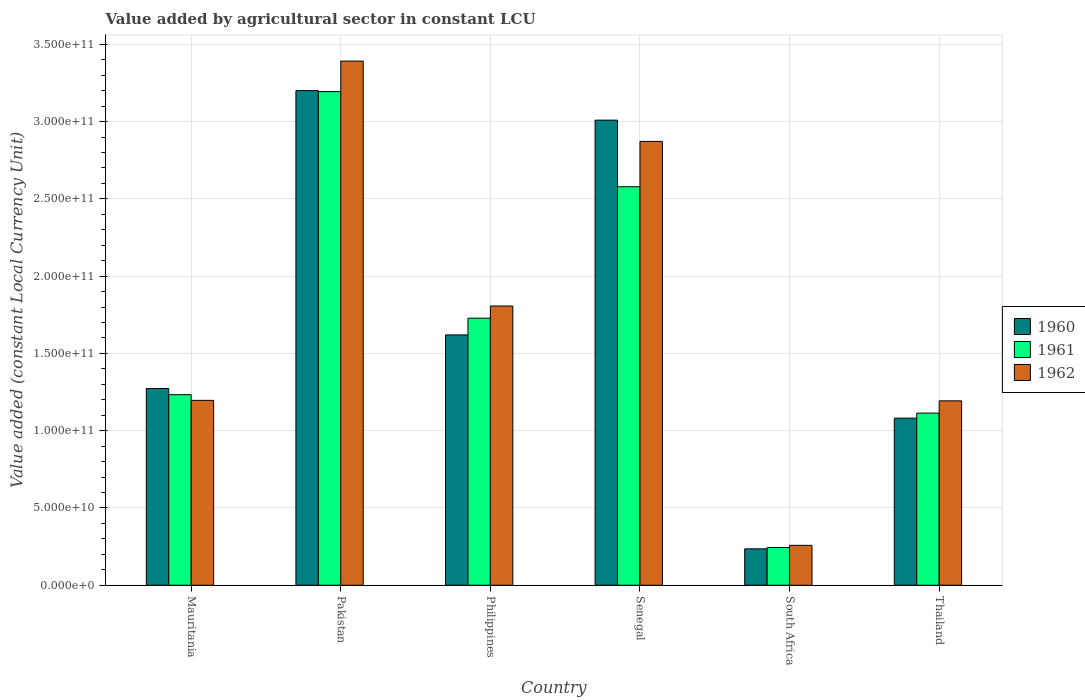How many different coloured bars are there?
Provide a short and direct response. 3. How many groups of bars are there?
Provide a succinct answer. 6. Are the number of bars on each tick of the X-axis equal?
Offer a very short reply. Yes. How many bars are there on the 5th tick from the left?
Ensure brevity in your answer.  3. How many bars are there on the 6th tick from the right?
Provide a short and direct response. 3. What is the label of the 3rd group of bars from the left?
Your response must be concise. Philippines. What is the value added by agricultural sector in 1961 in South Africa?
Provide a short and direct response. 2.44e+1. Across all countries, what is the maximum value added by agricultural sector in 1962?
Ensure brevity in your answer.  3.39e+11. Across all countries, what is the minimum value added by agricultural sector in 1960?
Give a very brief answer. 2.36e+1. In which country was the value added by agricultural sector in 1960 maximum?
Make the answer very short. Pakistan. In which country was the value added by agricultural sector in 1961 minimum?
Ensure brevity in your answer.  South Africa. What is the total value added by agricultural sector in 1962 in the graph?
Provide a short and direct response. 1.07e+12. What is the difference between the value added by agricultural sector in 1960 in Pakistan and that in Senegal?
Offer a very short reply. 1.91e+1. What is the difference between the value added by agricultural sector in 1962 in Philippines and the value added by agricultural sector in 1960 in Pakistan?
Ensure brevity in your answer.  -1.39e+11. What is the average value added by agricultural sector in 1962 per country?
Provide a succinct answer. 1.79e+11. What is the difference between the value added by agricultural sector of/in 1961 and value added by agricultural sector of/in 1962 in South Africa?
Give a very brief answer. -1.39e+09. In how many countries, is the value added by agricultural sector in 1960 greater than 250000000000 LCU?
Your answer should be very brief. 2. What is the ratio of the value added by agricultural sector in 1962 in Pakistan to that in South Africa?
Make the answer very short. 13.14. What is the difference between the highest and the second highest value added by agricultural sector in 1962?
Your answer should be very brief. -1.58e+11. What is the difference between the highest and the lowest value added by agricultural sector in 1960?
Make the answer very short. 2.97e+11. In how many countries, is the value added by agricultural sector in 1962 greater than the average value added by agricultural sector in 1962 taken over all countries?
Keep it short and to the point. 3. Is the sum of the value added by agricultural sector in 1961 in Mauritania and South Africa greater than the maximum value added by agricultural sector in 1962 across all countries?
Offer a very short reply. No. What does the 1st bar from the left in Thailand represents?
Your answer should be compact. 1960. How many bars are there?
Provide a succinct answer. 18. Does the graph contain grids?
Make the answer very short. Yes. How many legend labels are there?
Your response must be concise. 3. What is the title of the graph?
Offer a terse response. Value added by agricultural sector in constant LCU. What is the label or title of the Y-axis?
Offer a terse response. Value added (constant Local Currency Unit). What is the Value added (constant Local Currency Unit) of 1960 in Mauritania?
Give a very brief answer. 1.27e+11. What is the Value added (constant Local Currency Unit) in 1961 in Mauritania?
Make the answer very short. 1.23e+11. What is the Value added (constant Local Currency Unit) of 1962 in Mauritania?
Provide a succinct answer. 1.20e+11. What is the Value added (constant Local Currency Unit) in 1960 in Pakistan?
Your answer should be compact. 3.20e+11. What is the Value added (constant Local Currency Unit) in 1961 in Pakistan?
Ensure brevity in your answer.  3.19e+11. What is the Value added (constant Local Currency Unit) in 1962 in Pakistan?
Give a very brief answer. 3.39e+11. What is the Value added (constant Local Currency Unit) of 1960 in Philippines?
Provide a succinct answer. 1.62e+11. What is the Value added (constant Local Currency Unit) of 1961 in Philippines?
Keep it short and to the point. 1.73e+11. What is the Value added (constant Local Currency Unit) of 1962 in Philippines?
Make the answer very short. 1.81e+11. What is the Value added (constant Local Currency Unit) of 1960 in Senegal?
Give a very brief answer. 3.01e+11. What is the Value added (constant Local Currency Unit) in 1961 in Senegal?
Your answer should be compact. 2.58e+11. What is the Value added (constant Local Currency Unit) of 1962 in Senegal?
Your answer should be compact. 2.87e+11. What is the Value added (constant Local Currency Unit) in 1960 in South Africa?
Offer a terse response. 2.36e+1. What is the Value added (constant Local Currency Unit) of 1961 in South Africa?
Your response must be concise. 2.44e+1. What is the Value added (constant Local Currency Unit) of 1962 in South Africa?
Give a very brief answer. 2.58e+1. What is the Value added (constant Local Currency Unit) of 1960 in Thailand?
Keep it short and to the point. 1.08e+11. What is the Value added (constant Local Currency Unit) of 1961 in Thailand?
Ensure brevity in your answer.  1.11e+11. What is the Value added (constant Local Currency Unit) in 1962 in Thailand?
Your answer should be very brief. 1.19e+11. Across all countries, what is the maximum Value added (constant Local Currency Unit) in 1960?
Your answer should be very brief. 3.20e+11. Across all countries, what is the maximum Value added (constant Local Currency Unit) in 1961?
Ensure brevity in your answer.  3.19e+11. Across all countries, what is the maximum Value added (constant Local Currency Unit) of 1962?
Your response must be concise. 3.39e+11. Across all countries, what is the minimum Value added (constant Local Currency Unit) in 1960?
Ensure brevity in your answer.  2.36e+1. Across all countries, what is the minimum Value added (constant Local Currency Unit) in 1961?
Your response must be concise. 2.44e+1. Across all countries, what is the minimum Value added (constant Local Currency Unit) of 1962?
Your answer should be very brief. 2.58e+1. What is the total Value added (constant Local Currency Unit) of 1960 in the graph?
Ensure brevity in your answer.  1.04e+12. What is the total Value added (constant Local Currency Unit) in 1961 in the graph?
Your answer should be compact. 1.01e+12. What is the total Value added (constant Local Currency Unit) in 1962 in the graph?
Your answer should be compact. 1.07e+12. What is the difference between the Value added (constant Local Currency Unit) of 1960 in Mauritania and that in Pakistan?
Your answer should be compact. -1.93e+11. What is the difference between the Value added (constant Local Currency Unit) of 1961 in Mauritania and that in Pakistan?
Offer a terse response. -1.96e+11. What is the difference between the Value added (constant Local Currency Unit) in 1962 in Mauritania and that in Pakistan?
Your response must be concise. -2.20e+11. What is the difference between the Value added (constant Local Currency Unit) in 1960 in Mauritania and that in Philippines?
Offer a terse response. -3.47e+1. What is the difference between the Value added (constant Local Currency Unit) of 1961 in Mauritania and that in Philippines?
Ensure brevity in your answer.  -4.95e+1. What is the difference between the Value added (constant Local Currency Unit) of 1962 in Mauritania and that in Philippines?
Offer a terse response. -6.11e+1. What is the difference between the Value added (constant Local Currency Unit) of 1960 in Mauritania and that in Senegal?
Your response must be concise. -1.74e+11. What is the difference between the Value added (constant Local Currency Unit) of 1961 in Mauritania and that in Senegal?
Make the answer very short. -1.35e+11. What is the difference between the Value added (constant Local Currency Unit) of 1962 in Mauritania and that in Senegal?
Keep it short and to the point. -1.68e+11. What is the difference between the Value added (constant Local Currency Unit) of 1960 in Mauritania and that in South Africa?
Offer a very short reply. 1.04e+11. What is the difference between the Value added (constant Local Currency Unit) of 1961 in Mauritania and that in South Africa?
Your response must be concise. 9.88e+1. What is the difference between the Value added (constant Local Currency Unit) in 1962 in Mauritania and that in South Africa?
Offer a very short reply. 9.38e+1. What is the difference between the Value added (constant Local Currency Unit) of 1960 in Mauritania and that in Thailand?
Ensure brevity in your answer.  1.92e+1. What is the difference between the Value added (constant Local Currency Unit) of 1961 in Mauritania and that in Thailand?
Your response must be concise. 1.19e+1. What is the difference between the Value added (constant Local Currency Unit) of 1962 in Mauritania and that in Thailand?
Your answer should be very brief. 3.11e+08. What is the difference between the Value added (constant Local Currency Unit) of 1960 in Pakistan and that in Philippines?
Your response must be concise. 1.58e+11. What is the difference between the Value added (constant Local Currency Unit) of 1961 in Pakistan and that in Philippines?
Your answer should be very brief. 1.47e+11. What is the difference between the Value added (constant Local Currency Unit) of 1962 in Pakistan and that in Philippines?
Give a very brief answer. 1.58e+11. What is the difference between the Value added (constant Local Currency Unit) of 1960 in Pakistan and that in Senegal?
Offer a terse response. 1.91e+1. What is the difference between the Value added (constant Local Currency Unit) of 1961 in Pakistan and that in Senegal?
Your answer should be very brief. 6.16e+1. What is the difference between the Value added (constant Local Currency Unit) of 1962 in Pakistan and that in Senegal?
Provide a short and direct response. 5.20e+1. What is the difference between the Value added (constant Local Currency Unit) in 1960 in Pakistan and that in South Africa?
Provide a short and direct response. 2.97e+11. What is the difference between the Value added (constant Local Currency Unit) of 1961 in Pakistan and that in South Africa?
Provide a short and direct response. 2.95e+11. What is the difference between the Value added (constant Local Currency Unit) in 1962 in Pakistan and that in South Africa?
Offer a very short reply. 3.13e+11. What is the difference between the Value added (constant Local Currency Unit) in 1960 in Pakistan and that in Thailand?
Offer a terse response. 2.12e+11. What is the difference between the Value added (constant Local Currency Unit) of 1961 in Pakistan and that in Thailand?
Provide a succinct answer. 2.08e+11. What is the difference between the Value added (constant Local Currency Unit) of 1962 in Pakistan and that in Thailand?
Your answer should be very brief. 2.20e+11. What is the difference between the Value added (constant Local Currency Unit) of 1960 in Philippines and that in Senegal?
Offer a terse response. -1.39e+11. What is the difference between the Value added (constant Local Currency Unit) of 1961 in Philippines and that in Senegal?
Your answer should be compact. -8.50e+1. What is the difference between the Value added (constant Local Currency Unit) of 1962 in Philippines and that in Senegal?
Provide a succinct answer. -1.07e+11. What is the difference between the Value added (constant Local Currency Unit) of 1960 in Philippines and that in South Africa?
Your response must be concise. 1.38e+11. What is the difference between the Value added (constant Local Currency Unit) of 1961 in Philippines and that in South Africa?
Offer a terse response. 1.48e+11. What is the difference between the Value added (constant Local Currency Unit) in 1962 in Philippines and that in South Africa?
Your response must be concise. 1.55e+11. What is the difference between the Value added (constant Local Currency Unit) of 1960 in Philippines and that in Thailand?
Give a very brief answer. 5.39e+1. What is the difference between the Value added (constant Local Currency Unit) in 1961 in Philippines and that in Thailand?
Offer a terse response. 6.14e+1. What is the difference between the Value added (constant Local Currency Unit) in 1962 in Philippines and that in Thailand?
Provide a short and direct response. 6.14e+1. What is the difference between the Value added (constant Local Currency Unit) of 1960 in Senegal and that in South Africa?
Offer a terse response. 2.77e+11. What is the difference between the Value added (constant Local Currency Unit) in 1961 in Senegal and that in South Africa?
Offer a terse response. 2.33e+11. What is the difference between the Value added (constant Local Currency Unit) in 1962 in Senegal and that in South Africa?
Provide a succinct answer. 2.61e+11. What is the difference between the Value added (constant Local Currency Unit) of 1960 in Senegal and that in Thailand?
Your answer should be compact. 1.93e+11. What is the difference between the Value added (constant Local Currency Unit) in 1961 in Senegal and that in Thailand?
Ensure brevity in your answer.  1.46e+11. What is the difference between the Value added (constant Local Currency Unit) of 1962 in Senegal and that in Thailand?
Your response must be concise. 1.68e+11. What is the difference between the Value added (constant Local Currency Unit) of 1960 in South Africa and that in Thailand?
Offer a very short reply. -8.46e+1. What is the difference between the Value added (constant Local Currency Unit) of 1961 in South Africa and that in Thailand?
Keep it short and to the point. -8.70e+1. What is the difference between the Value added (constant Local Currency Unit) in 1962 in South Africa and that in Thailand?
Offer a terse response. -9.35e+1. What is the difference between the Value added (constant Local Currency Unit) in 1960 in Mauritania and the Value added (constant Local Currency Unit) in 1961 in Pakistan?
Keep it short and to the point. -1.92e+11. What is the difference between the Value added (constant Local Currency Unit) in 1960 in Mauritania and the Value added (constant Local Currency Unit) in 1962 in Pakistan?
Keep it short and to the point. -2.12e+11. What is the difference between the Value added (constant Local Currency Unit) in 1961 in Mauritania and the Value added (constant Local Currency Unit) in 1962 in Pakistan?
Your response must be concise. -2.16e+11. What is the difference between the Value added (constant Local Currency Unit) in 1960 in Mauritania and the Value added (constant Local Currency Unit) in 1961 in Philippines?
Keep it short and to the point. -4.55e+1. What is the difference between the Value added (constant Local Currency Unit) of 1960 in Mauritania and the Value added (constant Local Currency Unit) of 1962 in Philippines?
Provide a short and direct response. -5.34e+1. What is the difference between the Value added (constant Local Currency Unit) of 1961 in Mauritania and the Value added (constant Local Currency Unit) of 1962 in Philippines?
Your answer should be compact. -5.74e+1. What is the difference between the Value added (constant Local Currency Unit) in 1960 in Mauritania and the Value added (constant Local Currency Unit) in 1961 in Senegal?
Offer a terse response. -1.31e+11. What is the difference between the Value added (constant Local Currency Unit) of 1960 in Mauritania and the Value added (constant Local Currency Unit) of 1962 in Senegal?
Your response must be concise. -1.60e+11. What is the difference between the Value added (constant Local Currency Unit) in 1961 in Mauritania and the Value added (constant Local Currency Unit) in 1962 in Senegal?
Keep it short and to the point. -1.64e+11. What is the difference between the Value added (constant Local Currency Unit) of 1960 in Mauritania and the Value added (constant Local Currency Unit) of 1961 in South Africa?
Provide a short and direct response. 1.03e+11. What is the difference between the Value added (constant Local Currency Unit) in 1960 in Mauritania and the Value added (constant Local Currency Unit) in 1962 in South Africa?
Make the answer very short. 1.01e+11. What is the difference between the Value added (constant Local Currency Unit) in 1961 in Mauritania and the Value added (constant Local Currency Unit) in 1962 in South Africa?
Offer a terse response. 9.75e+1. What is the difference between the Value added (constant Local Currency Unit) of 1960 in Mauritania and the Value added (constant Local Currency Unit) of 1961 in Thailand?
Keep it short and to the point. 1.59e+1. What is the difference between the Value added (constant Local Currency Unit) in 1960 in Mauritania and the Value added (constant Local Currency Unit) in 1962 in Thailand?
Make the answer very short. 7.98e+09. What is the difference between the Value added (constant Local Currency Unit) of 1961 in Mauritania and the Value added (constant Local Currency Unit) of 1962 in Thailand?
Offer a terse response. 3.97e+09. What is the difference between the Value added (constant Local Currency Unit) of 1960 in Pakistan and the Value added (constant Local Currency Unit) of 1961 in Philippines?
Your response must be concise. 1.47e+11. What is the difference between the Value added (constant Local Currency Unit) in 1960 in Pakistan and the Value added (constant Local Currency Unit) in 1962 in Philippines?
Give a very brief answer. 1.39e+11. What is the difference between the Value added (constant Local Currency Unit) in 1961 in Pakistan and the Value added (constant Local Currency Unit) in 1962 in Philippines?
Ensure brevity in your answer.  1.39e+11. What is the difference between the Value added (constant Local Currency Unit) in 1960 in Pakistan and the Value added (constant Local Currency Unit) in 1961 in Senegal?
Make the answer very short. 6.22e+1. What is the difference between the Value added (constant Local Currency Unit) of 1960 in Pakistan and the Value added (constant Local Currency Unit) of 1962 in Senegal?
Provide a succinct answer. 3.29e+1. What is the difference between the Value added (constant Local Currency Unit) in 1961 in Pakistan and the Value added (constant Local Currency Unit) in 1962 in Senegal?
Give a very brief answer. 3.22e+1. What is the difference between the Value added (constant Local Currency Unit) in 1960 in Pakistan and the Value added (constant Local Currency Unit) in 1961 in South Africa?
Make the answer very short. 2.96e+11. What is the difference between the Value added (constant Local Currency Unit) of 1960 in Pakistan and the Value added (constant Local Currency Unit) of 1962 in South Africa?
Your answer should be compact. 2.94e+11. What is the difference between the Value added (constant Local Currency Unit) in 1961 in Pakistan and the Value added (constant Local Currency Unit) in 1962 in South Africa?
Your answer should be very brief. 2.94e+11. What is the difference between the Value added (constant Local Currency Unit) of 1960 in Pakistan and the Value added (constant Local Currency Unit) of 1961 in Thailand?
Offer a terse response. 2.09e+11. What is the difference between the Value added (constant Local Currency Unit) in 1960 in Pakistan and the Value added (constant Local Currency Unit) in 1962 in Thailand?
Offer a terse response. 2.01e+11. What is the difference between the Value added (constant Local Currency Unit) in 1961 in Pakistan and the Value added (constant Local Currency Unit) in 1962 in Thailand?
Make the answer very short. 2.00e+11. What is the difference between the Value added (constant Local Currency Unit) of 1960 in Philippines and the Value added (constant Local Currency Unit) of 1961 in Senegal?
Give a very brief answer. -9.59e+1. What is the difference between the Value added (constant Local Currency Unit) in 1960 in Philippines and the Value added (constant Local Currency Unit) in 1962 in Senegal?
Keep it short and to the point. -1.25e+11. What is the difference between the Value added (constant Local Currency Unit) in 1961 in Philippines and the Value added (constant Local Currency Unit) in 1962 in Senegal?
Your answer should be compact. -1.14e+11. What is the difference between the Value added (constant Local Currency Unit) in 1960 in Philippines and the Value added (constant Local Currency Unit) in 1961 in South Africa?
Provide a succinct answer. 1.38e+11. What is the difference between the Value added (constant Local Currency Unit) in 1960 in Philippines and the Value added (constant Local Currency Unit) in 1962 in South Africa?
Offer a very short reply. 1.36e+11. What is the difference between the Value added (constant Local Currency Unit) of 1961 in Philippines and the Value added (constant Local Currency Unit) of 1962 in South Africa?
Make the answer very short. 1.47e+11. What is the difference between the Value added (constant Local Currency Unit) of 1960 in Philippines and the Value added (constant Local Currency Unit) of 1961 in Thailand?
Give a very brief answer. 5.06e+1. What is the difference between the Value added (constant Local Currency Unit) of 1960 in Philippines and the Value added (constant Local Currency Unit) of 1962 in Thailand?
Your response must be concise. 4.27e+1. What is the difference between the Value added (constant Local Currency Unit) of 1961 in Philippines and the Value added (constant Local Currency Unit) of 1962 in Thailand?
Keep it short and to the point. 5.35e+1. What is the difference between the Value added (constant Local Currency Unit) of 1960 in Senegal and the Value added (constant Local Currency Unit) of 1961 in South Africa?
Your answer should be very brief. 2.77e+11. What is the difference between the Value added (constant Local Currency Unit) of 1960 in Senegal and the Value added (constant Local Currency Unit) of 1962 in South Africa?
Provide a short and direct response. 2.75e+11. What is the difference between the Value added (constant Local Currency Unit) of 1961 in Senegal and the Value added (constant Local Currency Unit) of 1962 in South Africa?
Make the answer very short. 2.32e+11. What is the difference between the Value added (constant Local Currency Unit) of 1960 in Senegal and the Value added (constant Local Currency Unit) of 1961 in Thailand?
Offer a very short reply. 1.90e+11. What is the difference between the Value added (constant Local Currency Unit) of 1960 in Senegal and the Value added (constant Local Currency Unit) of 1962 in Thailand?
Your answer should be compact. 1.82e+11. What is the difference between the Value added (constant Local Currency Unit) of 1961 in Senegal and the Value added (constant Local Currency Unit) of 1962 in Thailand?
Ensure brevity in your answer.  1.39e+11. What is the difference between the Value added (constant Local Currency Unit) in 1960 in South Africa and the Value added (constant Local Currency Unit) in 1961 in Thailand?
Make the answer very short. -8.78e+1. What is the difference between the Value added (constant Local Currency Unit) in 1960 in South Africa and the Value added (constant Local Currency Unit) in 1962 in Thailand?
Your response must be concise. -9.58e+1. What is the difference between the Value added (constant Local Currency Unit) in 1961 in South Africa and the Value added (constant Local Currency Unit) in 1962 in Thailand?
Your answer should be compact. -9.49e+1. What is the average Value added (constant Local Currency Unit) of 1960 per country?
Provide a short and direct response. 1.74e+11. What is the average Value added (constant Local Currency Unit) in 1961 per country?
Ensure brevity in your answer.  1.68e+11. What is the average Value added (constant Local Currency Unit) of 1962 per country?
Give a very brief answer. 1.79e+11. What is the difference between the Value added (constant Local Currency Unit) in 1960 and Value added (constant Local Currency Unit) in 1961 in Mauritania?
Make the answer very short. 4.01e+09. What is the difference between the Value added (constant Local Currency Unit) of 1960 and Value added (constant Local Currency Unit) of 1962 in Mauritania?
Your answer should be very brief. 7.67e+09. What is the difference between the Value added (constant Local Currency Unit) of 1961 and Value added (constant Local Currency Unit) of 1962 in Mauritania?
Your answer should be very brief. 3.65e+09. What is the difference between the Value added (constant Local Currency Unit) in 1960 and Value added (constant Local Currency Unit) in 1961 in Pakistan?
Offer a terse response. 6.46e+08. What is the difference between the Value added (constant Local Currency Unit) of 1960 and Value added (constant Local Currency Unit) of 1962 in Pakistan?
Make the answer very short. -1.91e+1. What is the difference between the Value added (constant Local Currency Unit) in 1961 and Value added (constant Local Currency Unit) in 1962 in Pakistan?
Ensure brevity in your answer.  -1.97e+1. What is the difference between the Value added (constant Local Currency Unit) of 1960 and Value added (constant Local Currency Unit) of 1961 in Philippines?
Keep it short and to the point. -1.08e+1. What is the difference between the Value added (constant Local Currency Unit) of 1960 and Value added (constant Local Currency Unit) of 1962 in Philippines?
Ensure brevity in your answer.  -1.87e+1. What is the difference between the Value added (constant Local Currency Unit) in 1961 and Value added (constant Local Currency Unit) in 1962 in Philippines?
Your answer should be compact. -7.86e+09. What is the difference between the Value added (constant Local Currency Unit) of 1960 and Value added (constant Local Currency Unit) of 1961 in Senegal?
Provide a succinct answer. 4.31e+1. What is the difference between the Value added (constant Local Currency Unit) of 1960 and Value added (constant Local Currency Unit) of 1962 in Senegal?
Provide a succinct answer. 1.38e+1. What is the difference between the Value added (constant Local Currency Unit) in 1961 and Value added (constant Local Currency Unit) in 1962 in Senegal?
Offer a terse response. -2.93e+1. What is the difference between the Value added (constant Local Currency Unit) in 1960 and Value added (constant Local Currency Unit) in 1961 in South Africa?
Your answer should be very brief. -8.75e+08. What is the difference between the Value added (constant Local Currency Unit) of 1960 and Value added (constant Local Currency Unit) of 1962 in South Africa?
Make the answer very short. -2.26e+09. What is the difference between the Value added (constant Local Currency Unit) of 1961 and Value added (constant Local Currency Unit) of 1962 in South Africa?
Your answer should be compact. -1.39e+09. What is the difference between the Value added (constant Local Currency Unit) of 1960 and Value added (constant Local Currency Unit) of 1961 in Thailand?
Ensure brevity in your answer.  -3.26e+09. What is the difference between the Value added (constant Local Currency Unit) in 1960 and Value added (constant Local Currency Unit) in 1962 in Thailand?
Offer a very short reply. -1.12e+1. What is the difference between the Value added (constant Local Currency Unit) of 1961 and Value added (constant Local Currency Unit) of 1962 in Thailand?
Your response must be concise. -7.93e+09. What is the ratio of the Value added (constant Local Currency Unit) in 1960 in Mauritania to that in Pakistan?
Make the answer very short. 0.4. What is the ratio of the Value added (constant Local Currency Unit) of 1961 in Mauritania to that in Pakistan?
Your answer should be very brief. 0.39. What is the ratio of the Value added (constant Local Currency Unit) in 1962 in Mauritania to that in Pakistan?
Provide a succinct answer. 0.35. What is the ratio of the Value added (constant Local Currency Unit) in 1960 in Mauritania to that in Philippines?
Ensure brevity in your answer.  0.79. What is the ratio of the Value added (constant Local Currency Unit) of 1961 in Mauritania to that in Philippines?
Make the answer very short. 0.71. What is the ratio of the Value added (constant Local Currency Unit) in 1962 in Mauritania to that in Philippines?
Your answer should be very brief. 0.66. What is the ratio of the Value added (constant Local Currency Unit) of 1960 in Mauritania to that in Senegal?
Make the answer very short. 0.42. What is the ratio of the Value added (constant Local Currency Unit) in 1961 in Mauritania to that in Senegal?
Your answer should be very brief. 0.48. What is the ratio of the Value added (constant Local Currency Unit) of 1962 in Mauritania to that in Senegal?
Offer a very short reply. 0.42. What is the ratio of the Value added (constant Local Currency Unit) in 1960 in Mauritania to that in South Africa?
Your answer should be very brief. 5.4. What is the ratio of the Value added (constant Local Currency Unit) in 1961 in Mauritania to that in South Africa?
Keep it short and to the point. 5.05. What is the ratio of the Value added (constant Local Currency Unit) in 1962 in Mauritania to that in South Africa?
Provide a short and direct response. 4.63. What is the ratio of the Value added (constant Local Currency Unit) of 1960 in Mauritania to that in Thailand?
Your response must be concise. 1.18. What is the ratio of the Value added (constant Local Currency Unit) of 1961 in Mauritania to that in Thailand?
Give a very brief answer. 1.11. What is the ratio of the Value added (constant Local Currency Unit) in 1960 in Pakistan to that in Philippines?
Your response must be concise. 1.98. What is the ratio of the Value added (constant Local Currency Unit) of 1961 in Pakistan to that in Philippines?
Give a very brief answer. 1.85. What is the ratio of the Value added (constant Local Currency Unit) in 1962 in Pakistan to that in Philippines?
Give a very brief answer. 1.88. What is the ratio of the Value added (constant Local Currency Unit) in 1960 in Pakistan to that in Senegal?
Provide a succinct answer. 1.06. What is the ratio of the Value added (constant Local Currency Unit) in 1961 in Pakistan to that in Senegal?
Offer a very short reply. 1.24. What is the ratio of the Value added (constant Local Currency Unit) in 1962 in Pakistan to that in Senegal?
Your response must be concise. 1.18. What is the ratio of the Value added (constant Local Currency Unit) of 1960 in Pakistan to that in South Africa?
Provide a succinct answer. 13.59. What is the ratio of the Value added (constant Local Currency Unit) in 1961 in Pakistan to that in South Africa?
Your answer should be compact. 13.07. What is the ratio of the Value added (constant Local Currency Unit) of 1962 in Pakistan to that in South Africa?
Your response must be concise. 13.14. What is the ratio of the Value added (constant Local Currency Unit) in 1960 in Pakistan to that in Thailand?
Ensure brevity in your answer.  2.96. What is the ratio of the Value added (constant Local Currency Unit) in 1961 in Pakistan to that in Thailand?
Give a very brief answer. 2.87. What is the ratio of the Value added (constant Local Currency Unit) of 1962 in Pakistan to that in Thailand?
Keep it short and to the point. 2.84. What is the ratio of the Value added (constant Local Currency Unit) of 1960 in Philippines to that in Senegal?
Give a very brief answer. 0.54. What is the ratio of the Value added (constant Local Currency Unit) of 1961 in Philippines to that in Senegal?
Your answer should be very brief. 0.67. What is the ratio of the Value added (constant Local Currency Unit) of 1962 in Philippines to that in Senegal?
Your answer should be very brief. 0.63. What is the ratio of the Value added (constant Local Currency Unit) of 1960 in Philippines to that in South Africa?
Offer a very short reply. 6.88. What is the ratio of the Value added (constant Local Currency Unit) of 1961 in Philippines to that in South Africa?
Your answer should be very brief. 7.07. What is the ratio of the Value added (constant Local Currency Unit) in 1962 in Philippines to that in South Africa?
Your response must be concise. 7. What is the ratio of the Value added (constant Local Currency Unit) of 1960 in Philippines to that in Thailand?
Ensure brevity in your answer.  1.5. What is the ratio of the Value added (constant Local Currency Unit) of 1961 in Philippines to that in Thailand?
Provide a short and direct response. 1.55. What is the ratio of the Value added (constant Local Currency Unit) of 1962 in Philippines to that in Thailand?
Keep it short and to the point. 1.51. What is the ratio of the Value added (constant Local Currency Unit) of 1960 in Senegal to that in South Africa?
Your answer should be very brief. 12.77. What is the ratio of the Value added (constant Local Currency Unit) in 1961 in Senegal to that in South Africa?
Keep it short and to the point. 10.55. What is the ratio of the Value added (constant Local Currency Unit) in 1962 in Senegal to that in South Africa?
Provide a short and direct response. 11.12. What is the ratio of the Value added (constant Local Currency Unit) of 1960 in Senegal to that in Thailand?
Make the answer very short. 2.78. What is the ratio of the Value added (constant Local Currency Unit) in 1961 in Senegal to that in Thailand?
Ensure brevity in your answer.  2.31. What is the ratio of the Value added (constant Local Currency Unit) of 1962 in Senegal to that in Thailand?
Your answer should be very brief. 2.41. What is the ratio of the Value added (constant Local Currency Unit) in 1960 in South Africa to that in Thailand?
Provide a succinct answer. 0.22. What is the ratio of the Value added (constant Local Currency Unit) of 1961 in South Africa to that in Thailand?
Ensure brevity in your answer.  0.22. What is the ratio of the Value added (constant Local Currency Unit) of 1962 in South Africa to that in Thailand?
Make the answer very short. 0.22. What is the difference between the highest and the second highest Value added (constant Local Currency Unit) in 1960?
Offer a very short reply. 1.91e+1. What is the difference between the highest and the second highest Value added (constant Local Currency Unit) of 1961?
Keep it short and to the point. 6.16e+1. What is the difference between the highest and the second highest Value added (constant Local Currency Unit) of 1962?
Ensure brevity in your answer.  5.20e+1. What is the difference between the highest and the lowest Value added (constant Local Currency Unit) in 1960?
Your answer should be compact. 2.97e+11. What is the difference between the highest and the lowest Value added (constant Local Currency Unit) in 1961?
Make the answer very short. 2.95e+11. What is the difference between the highest and the lowest Value added (constant Local Currency Unit) in 1962?
Give a very brief answer. 3.13e+11. 